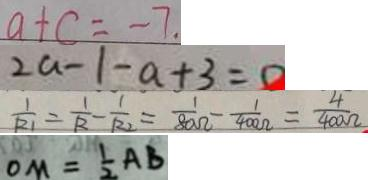<formula> <loc_0><loc_0><loc_500><loc_500>a + c = - 7 . 
 2 a - 1 - a + 3 = 0 
 \frac { 1 } { R _ { 1 } } = \frac { 1 } { R } - \frac { 1 } { R _ { 2 } } = \frac { 1 } { 8 0 \Omega } - \frac { 1 } { 4 0 0 \Omega } = \frac { 4 } { 4 0 0 \Omega } 
 O M = \frac { 1 } { 2 } A B</formula> 